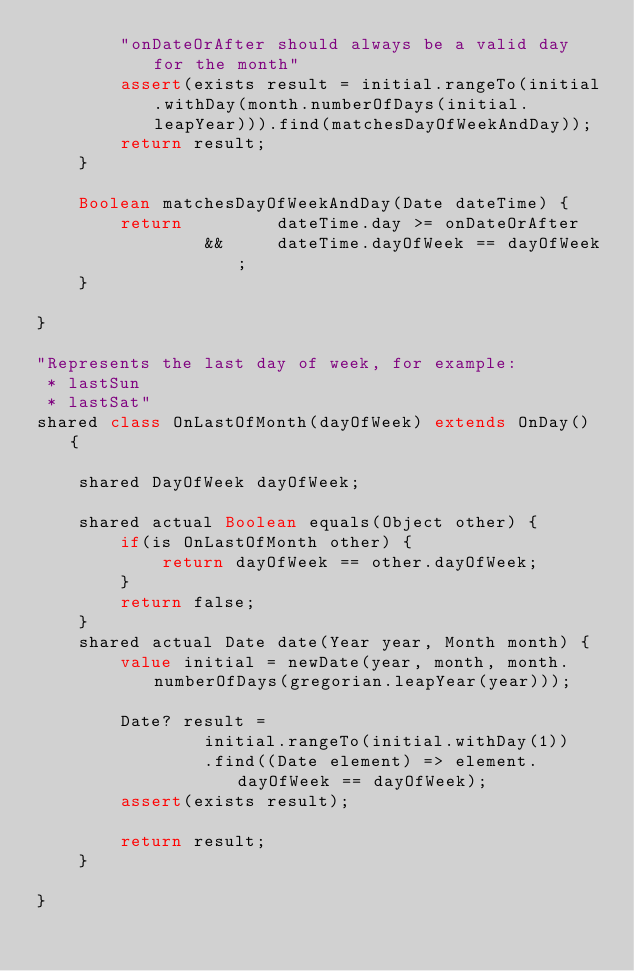Convert code to text. <code><loc_0><loc_0><loc_500><loc_500><_Ceylon_>        "onDateOrAfter should always be a valid day for the month"
        assert(exists result = initial.rangeTo(initial.withDay(month.numberOfDays(initial.leapYear))).find(matchesDayOfWeekAndDay));
        return result;
    }
    
    Boolean matchesDayOfWeekAndDay(Date dateTime) {
        return         dateTime.day >= onDateOrAfter
                &&     dateTime.dayOfWeek == dayOfWeek;
    }
    
}

"Represents the last day of week, for example:
 * lastSun
 * lastSat"
shared class OnLastOfMonth(dayOfWeek) extends OnDay() {
    
    shared DayOfWeek dayOfWeek;
    
    shared actual Boolean equals(Object other) {
        if(is OnLastOfMonth other) {
            return dayOfWeek == other.dayOfWeek;
        }
        return false;
    }
    shared actual Date date(Year year, Month month) {
        value initial = newDate(year, month, month.numberOfDays(gregorian.leapYear(year)));
        
        Date? result =
                initial.rangeTo(initial.withDay(1))
                .find((Date element) => element.dayOfWeek == dayOfWeek);
        assert(exists result);
        
        return result;
    }

}</code> 